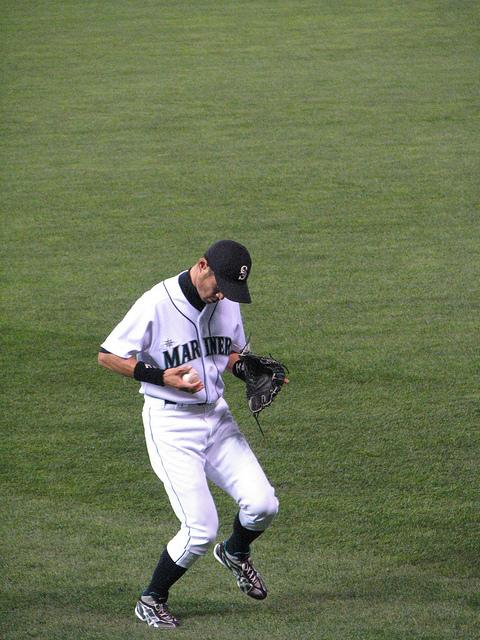Why is the man wearing a glove? catch ball 